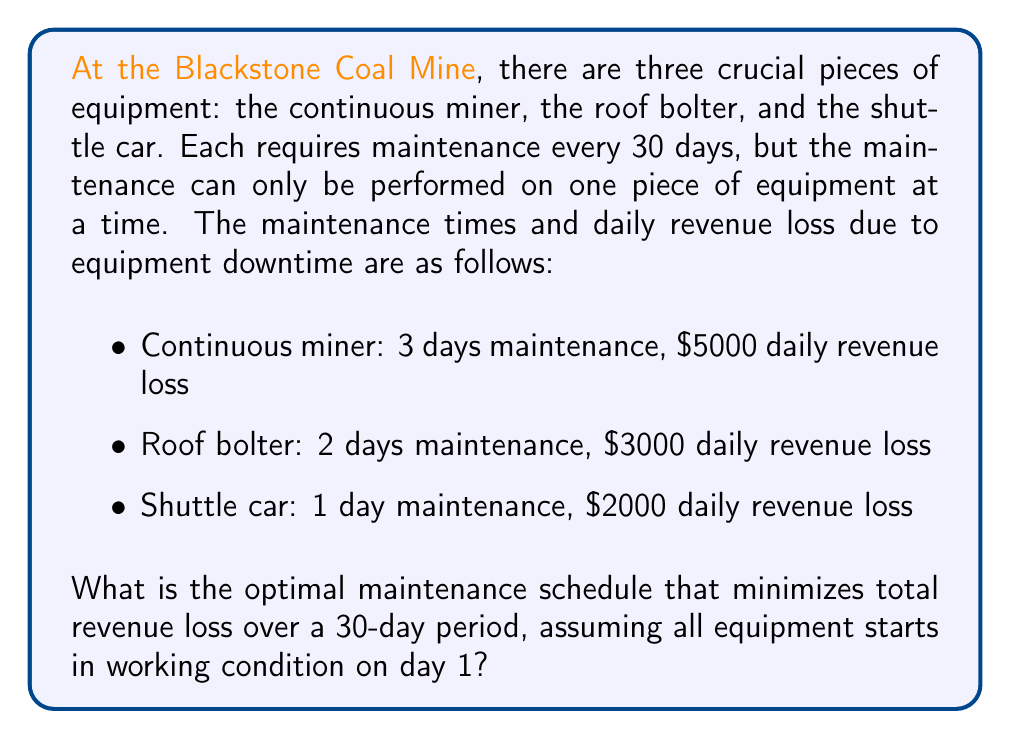Provide a solution to this math problem. To solve this problem, we'll use a simple scheduling approach:

1. Calculate the total revenue loss for each piece of equipment:
   - Continuous miner: $5000 * 3 = $15,000
   - Roof bolter: $3000 * 2 = $6,000
   - Shuttle car: $2000 * 1 = $2,000

2. Order the equipment from highest to lowest total revenue loss:
   1. Continuous miner
   2. Roof bolter
   3. Shuttle car

3. Schedule maintenance in this order, starting from day 1:
   - Day 1-3: Continuous miner
   - Day 4-5: Roof bolter
   - Day 6: Shuttle car

4. Calculate total revenue loss:
   $15,000 + $6,000 + $2,000 = $23,000

This schedule ensures that all equipment is maintained within the 30-day period while minimizing total revenue loss. Any other arrangement would result in higher losses.

To verify:
- If we schedule roof bolter first: 2 days * $3000 = $6,000
- Then continuous miner: 3 days * $5000 = $15,000
- Then shuttle car: 1 day * $2000 = $2,000
Total: $23,000

This matches our original calculation, confirming that the order doesn't affect the total revenue loss as long as all maintenance is completed within the 30-day period.
Answer: The optimal maintenance schedule is:
Days 1-3: Continuous miner
Days 4-5: Roof bolter
Day 6: Shuttle car

Total revenue loss: $23,000 